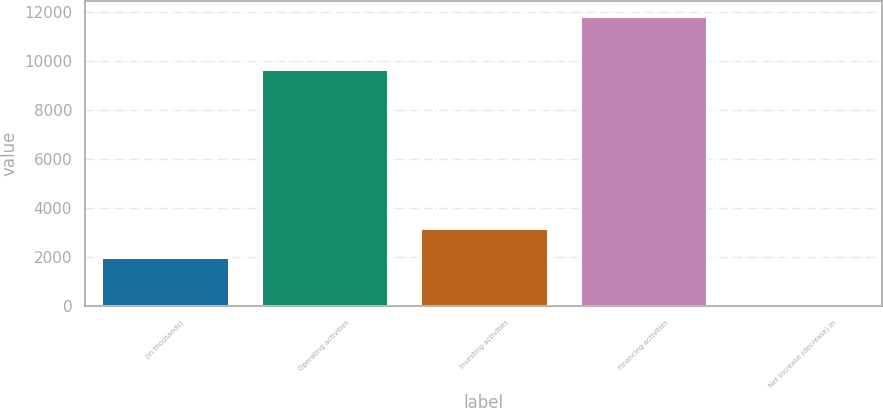<chart> <loc_0><loc_0><loc_500><loc_500><bar_chart><fcel>(in thousands)<fcel>Operating activities<fcel>Investing activities<fcel>Financing activities<fcel>Net increase (decrease) in<nl><fcel>2003<fcel>9702<fcel>3176.3<fcel>11860<fcel>127<nl></chart> 